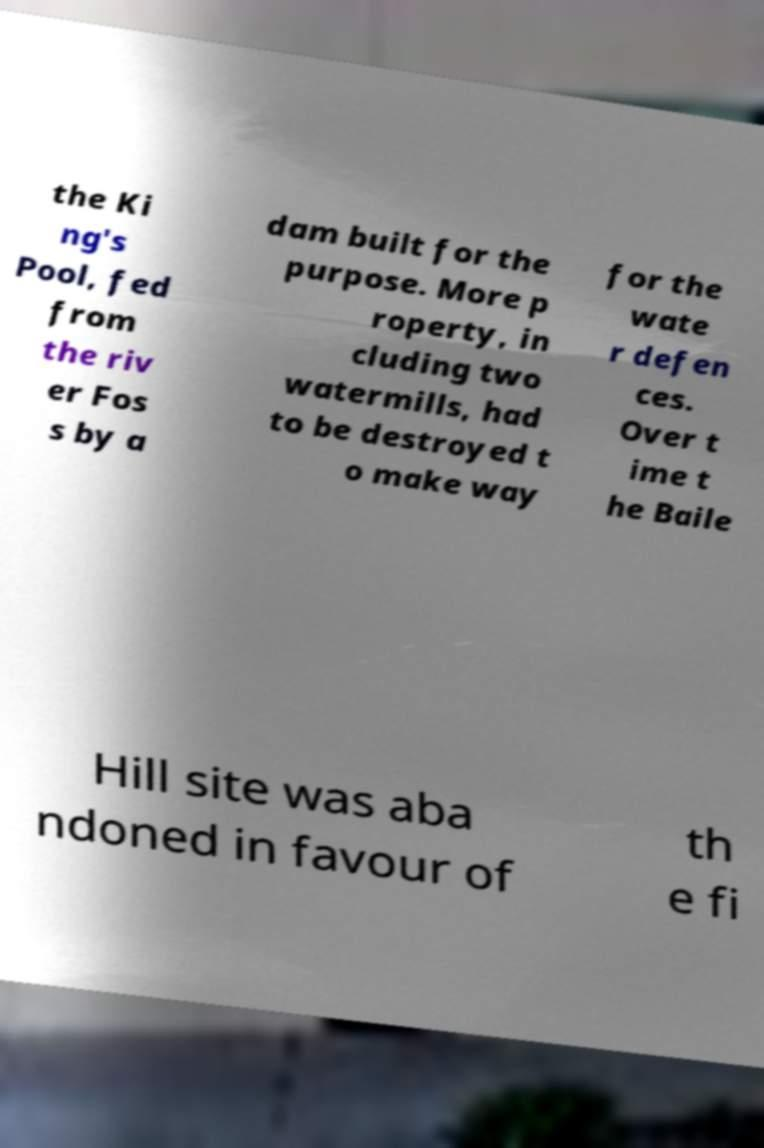Can you accurately transcribe the text from the provided image for me? the Ki ng's Pool, fed from the riv er Fos s by a dam built for the purpose. More p roperty, in cluding two watermills, had to be destroyed t o make way for the wate r defen ces. Over t ime t he Baile Hill site was aba ndoned in favour of th e fi 